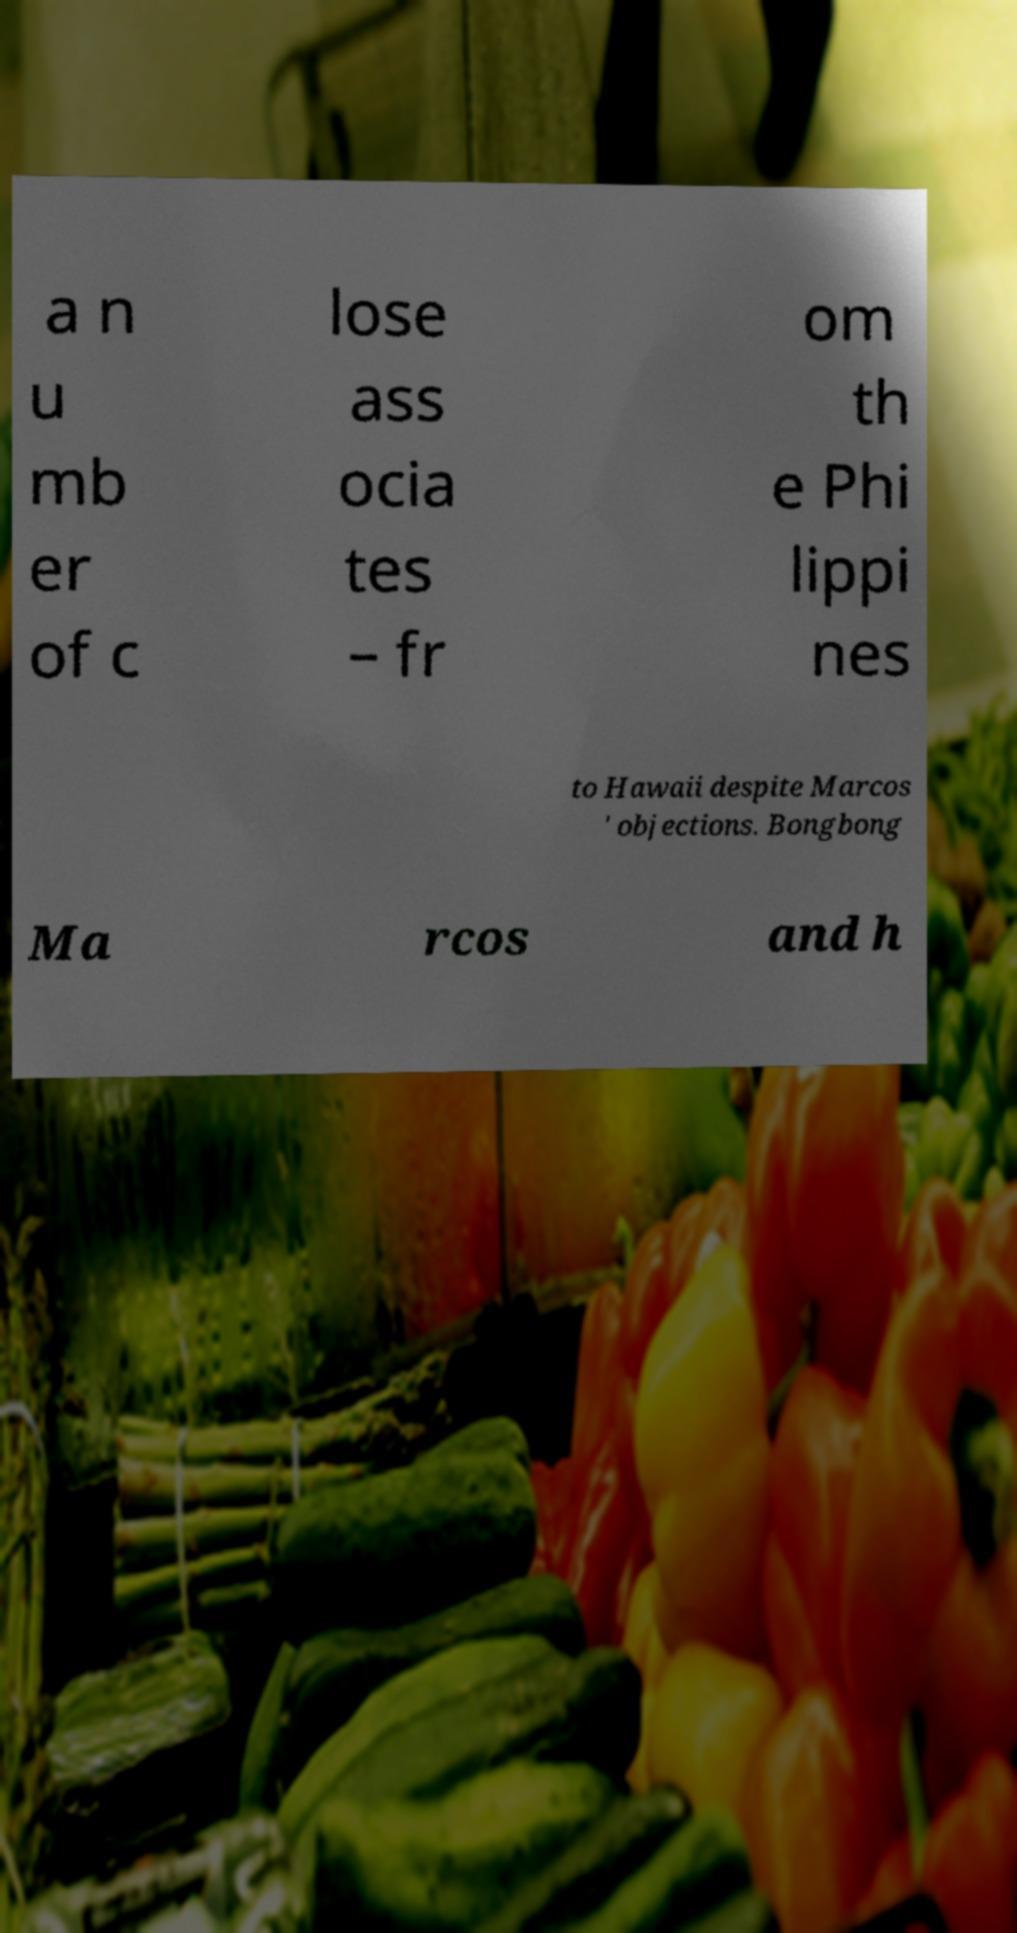Please identify and transcribe the text found in this image. a n u mb er of c lose ass ocia tes – fr om th e Phi lippi nes to Hawaii despite Marcos ' objections. Bongbong Ma rcos and h 